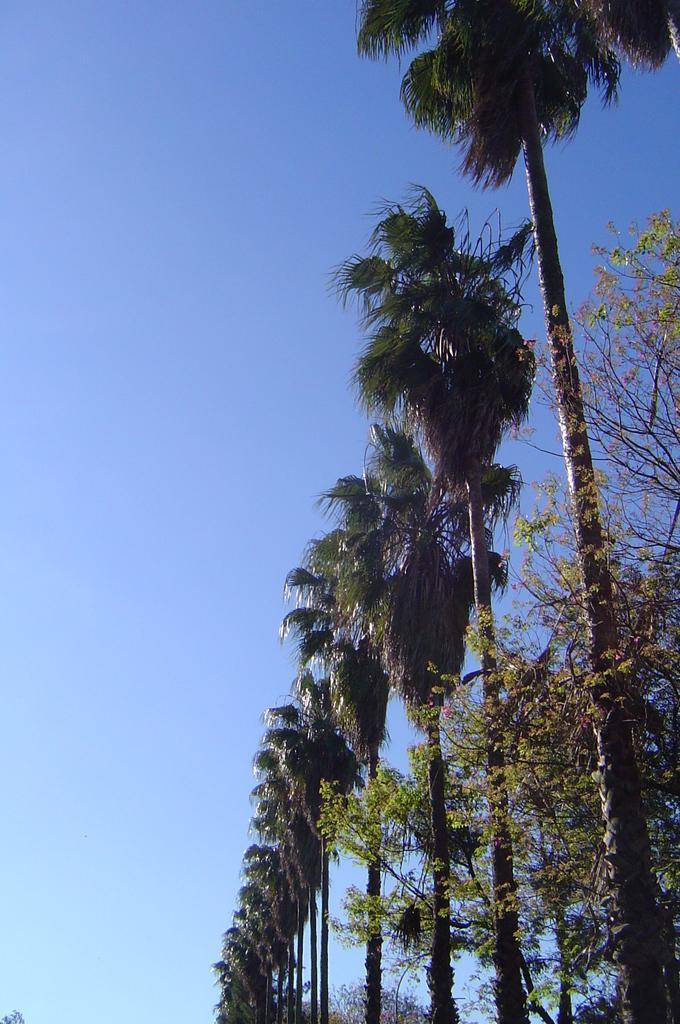Can you describe this image briefly? In this image we can see that there are tall trees in the line. At the top there is sky. On the right side there is a plant. 